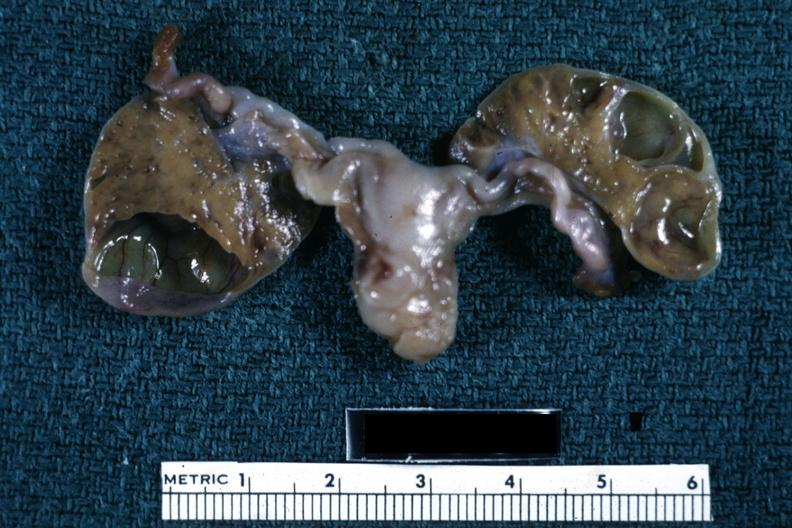what is present?
Answer the question using a single word or phrase. Ovary 